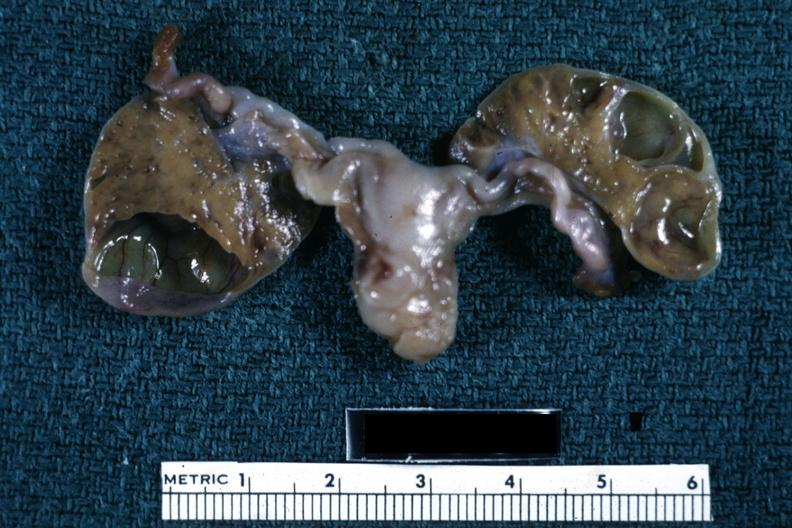what is present?
Answer the question using a single word or phrase. Ovary 